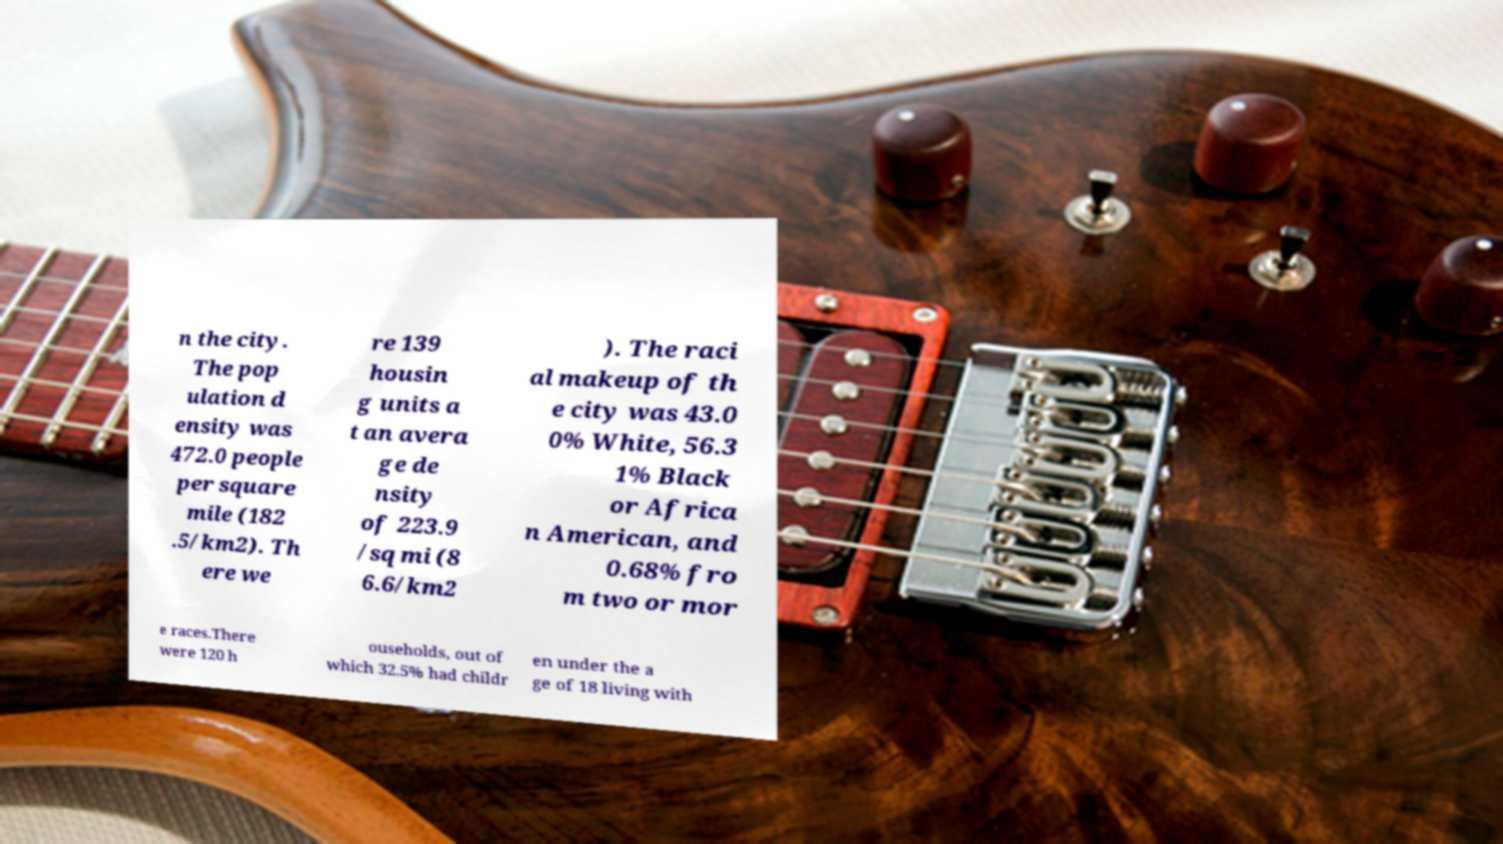What messages or text are displayed in this image? I need them in a readable, typed format. n the city. The pop ulation d ensity was 472.0 people per square mile (182 .5/km2). Th ere we re 139 housin g units a t an avera ge de nsity of 223.9 /sq mi (8 6.6/km2 ). The raci al makeup of th e city was 43.0 0% White, 56.3 1% Black or Africa n American, and 0.68% fro m two or mor e races.There were 120 h ouseholds, out of which 32.5% had childr en under the a ge of 18 living with 